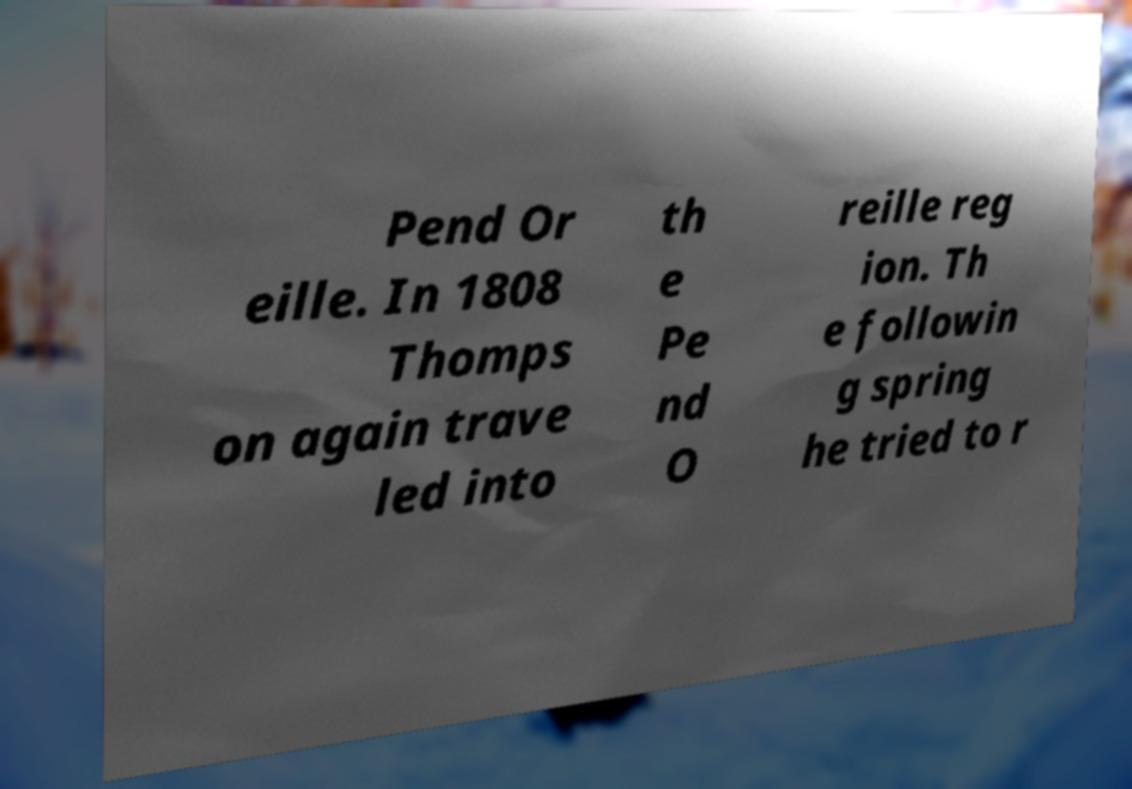Please read and relay the text visible in this image. What does it say? Pend Or eille. In 1808 Thomps on again trave led into th e Pe nd O reille reg ion. Th e followin g spring he tried to r 